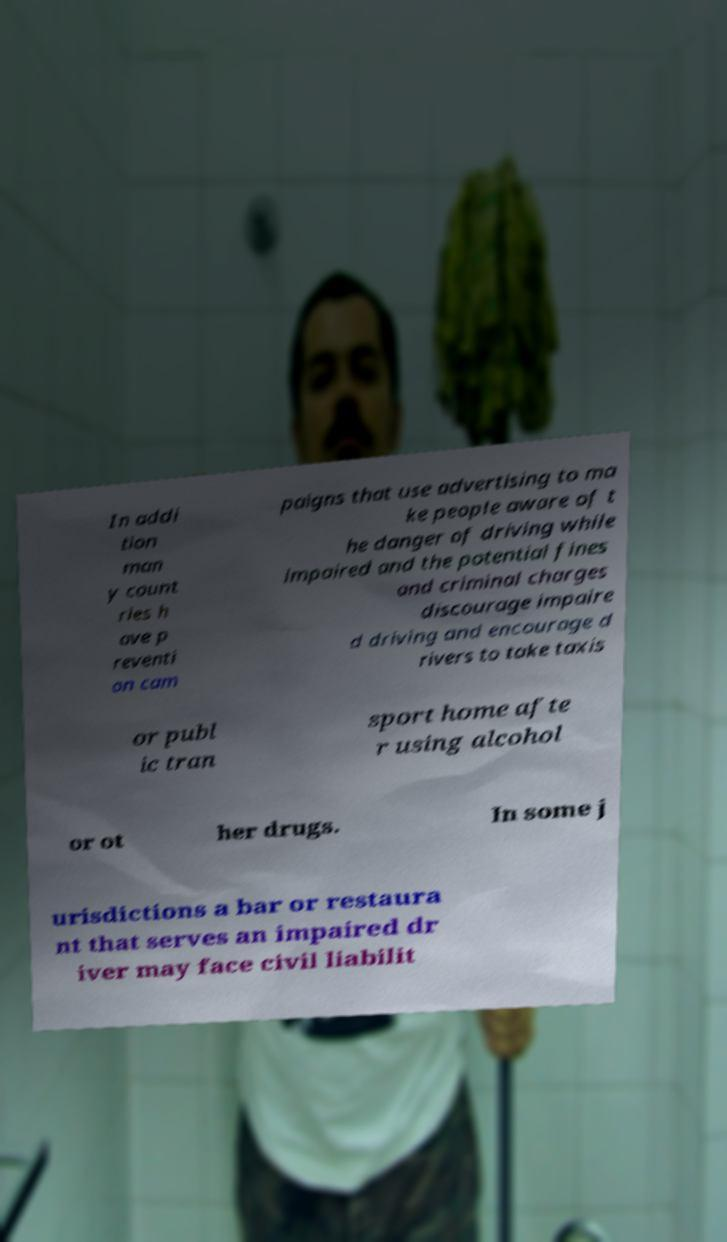Can you read and provide the text displayed in the image?This photo seems to have some interesting text. Can you extract and type it out for me? In addi tion man y count ries h ave p reventi on cam paigns that use advertising to ma ke people aware of t he danger of driving while impaired and the potential fines and criminal charges discourage impaire d driving and encourage d rivers to take taxis or publ ic tran sport home afte r using alcohol or ot her drugs. In some j urisdictions a bar or restaura nt that serves an impaired dr iver may face civil liabilit 